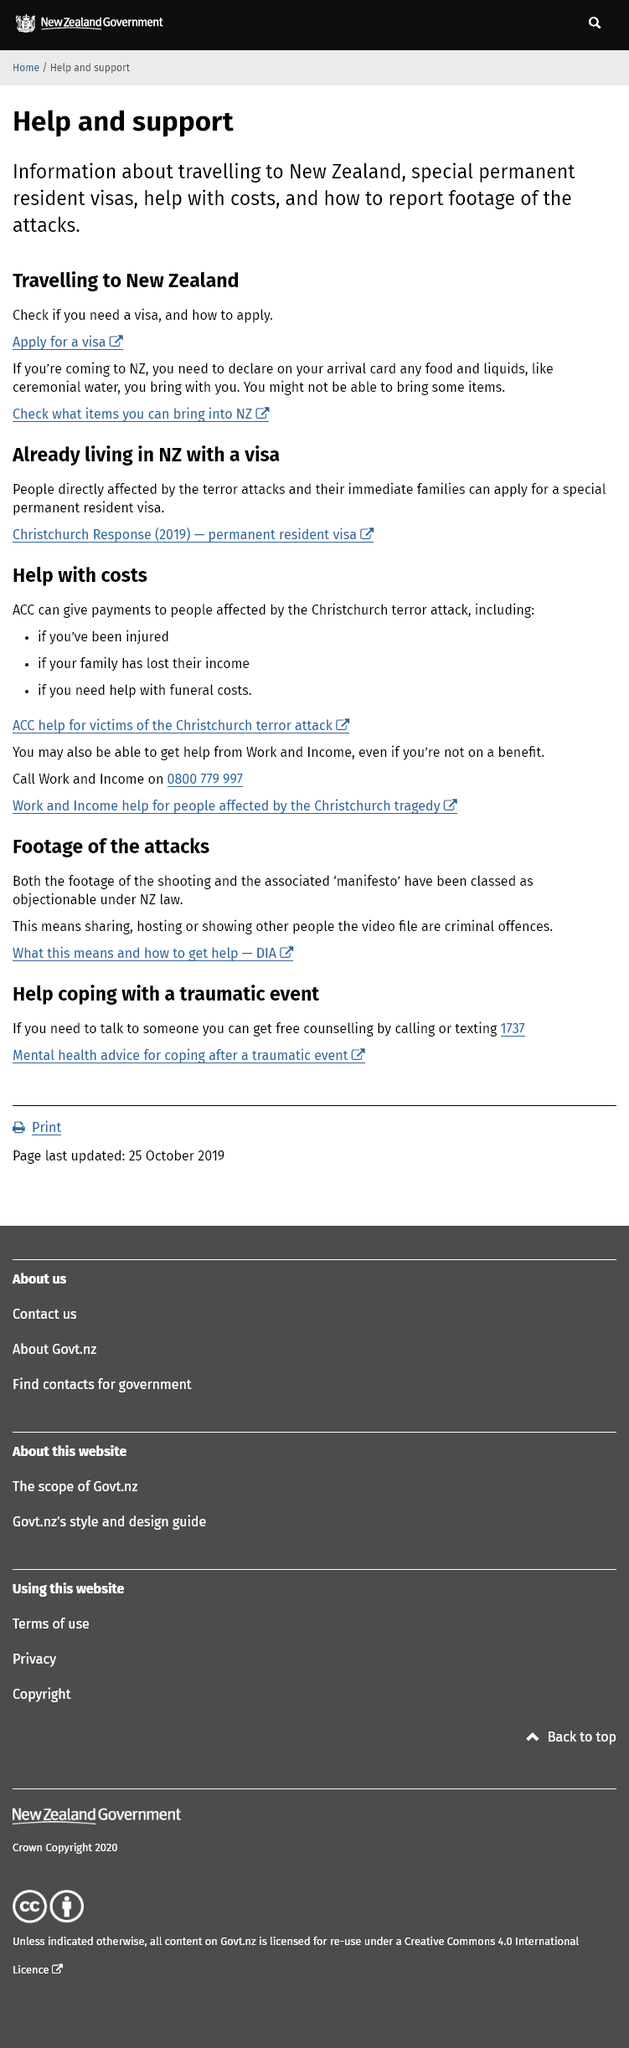Identify some key points in this picture. If you are arriving in New Zealand, you must declare any food and liquids, such as ceremonial water, on your arrival card. The information provided pertains to New Zealand. You have the ability to receive assistance and support on how to report footage of the content, and how to report footage of the attacks. 